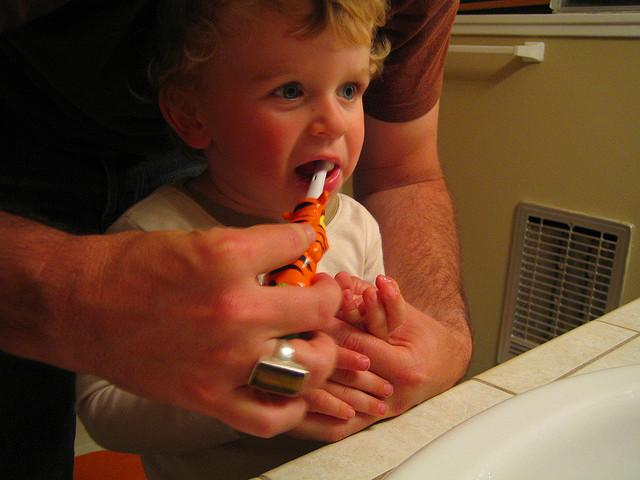What type of animal is the cartoon figure portrayed here based? Please explain your reasoning. tiger. A boy is holding a tigger toothbrush. tigger is from the show winnie the pooh and he is a tiger. 